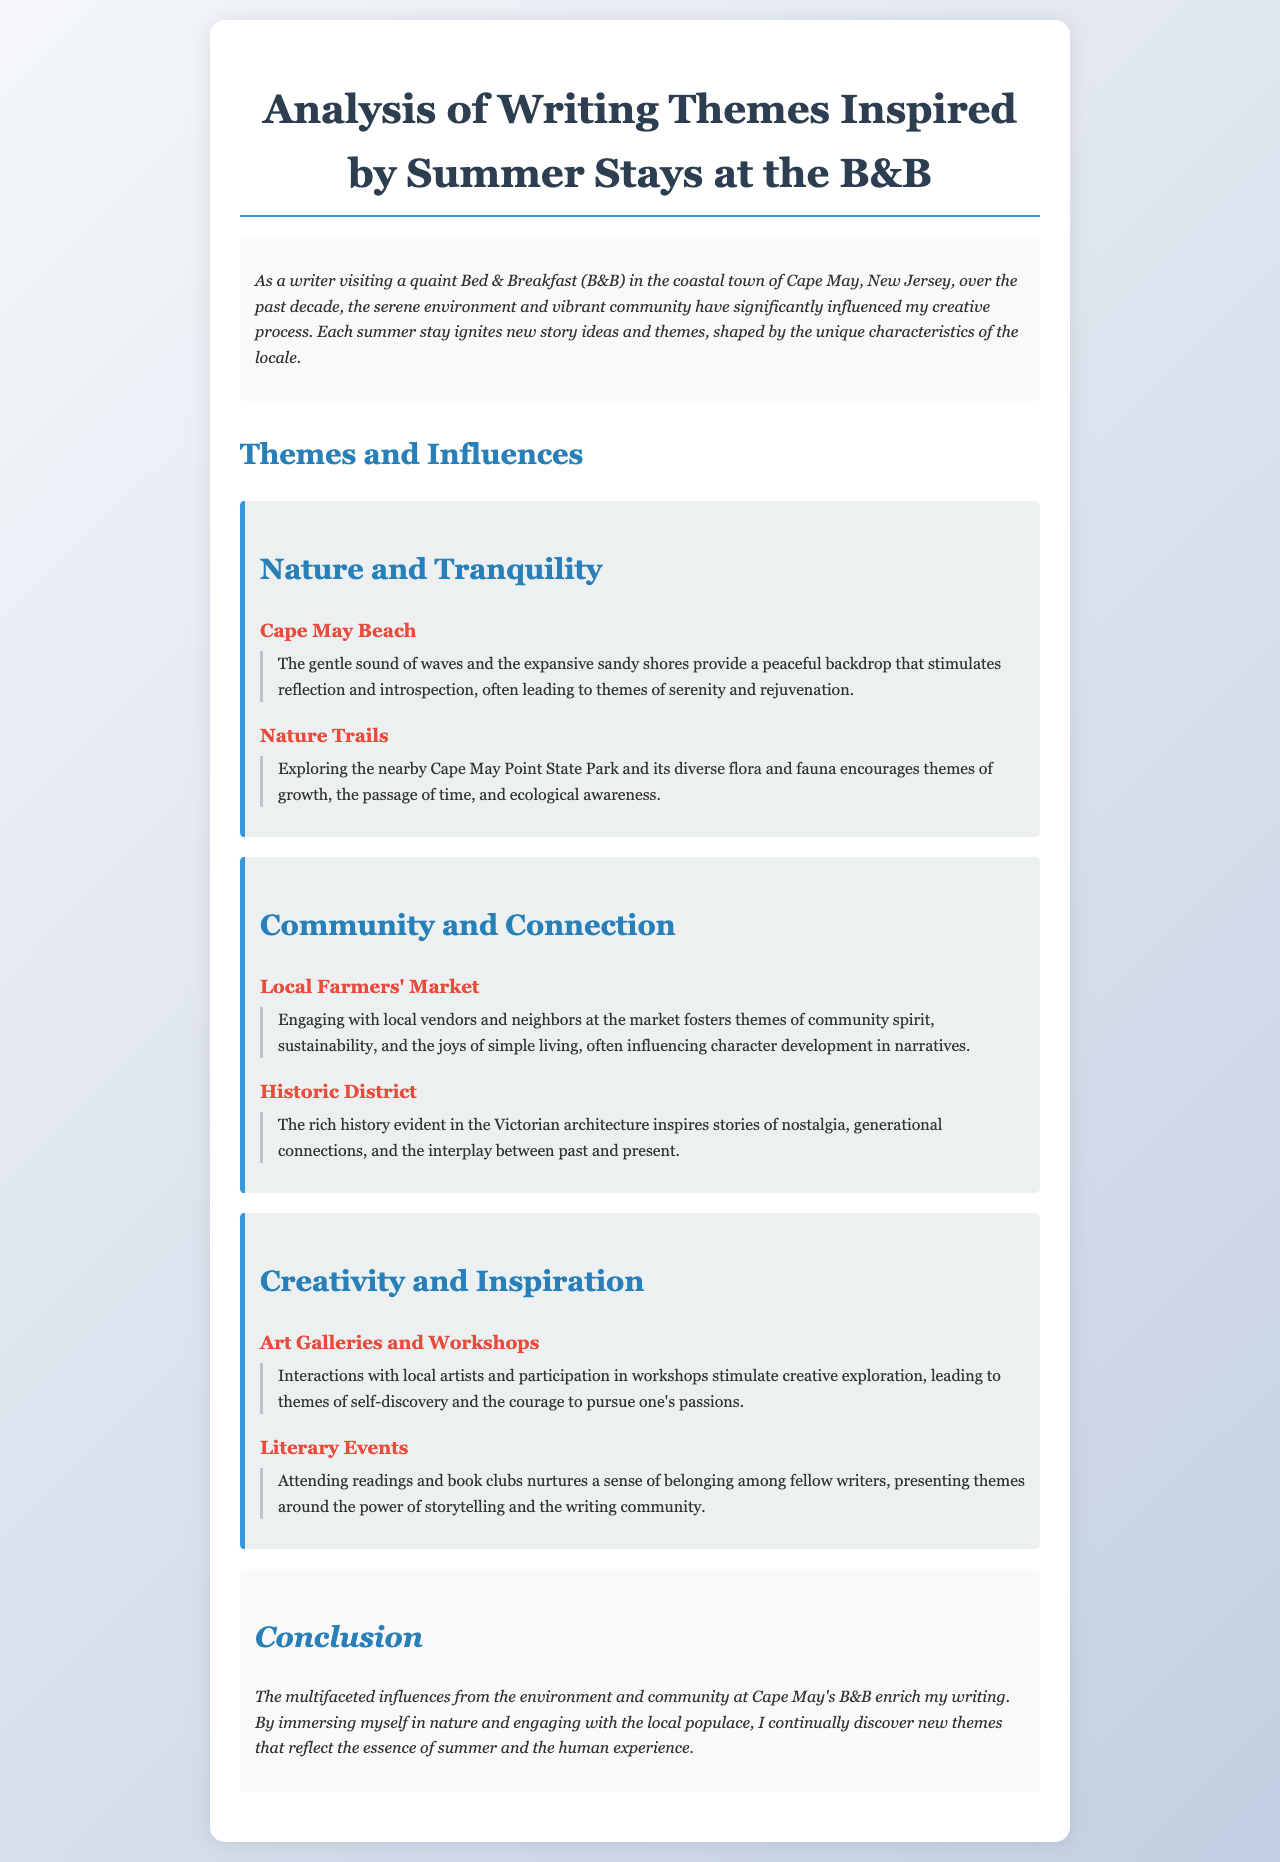What is the title of the report? The title of the report is the first heading in the document, which provides a summary of the content.
Answer: Analysis of Writing Themes Inspired by Summer Stays at the B&B What is one of the primary themes discussed in the report? The report discusses various themes. "Nature and Tranquility" is listed as one prominent theme.
Answer: Nature and Tranquility Where is the B&B located? The document mentions the coastal town of Cape May, New Jersey, as the location of the B&B.
Answer: Cape May, New Jersey What influences the theme of "Community and Connection"? The report provides specific influences under this theme, such as the "Local Farmers' Market" and "Historic District."
Answer: Local Farmers' Market Name one specific place mentioned that contributes to the "Creativity and Inspiration" theme. The section on "Creativity and Inspiration" includes influences such as "Art Galleries and Workshops."
Answer: Art Galleries and Workshops What type of interaction at local markets affects character development? The document states that engaging with local vendors and neighbors fosters themes important for character development.
Answer: Local vendors and neighbors How does the environment contribute to story themes? The conclusion emphasizes that the environment and community at the B&B enrich the author's writing, influencing new themes.
Answer: Enrich the author's writing What color is used for the main headings in the document? The main headings in the document use a blue color, specifically "#2980b9".
Answer: Blue What literary activity is mentioned that nurtures a sense of belonging? The report refers to "literary events," such as readings and book clubs, as activities that nurture belonging.
Answer: Literary events 